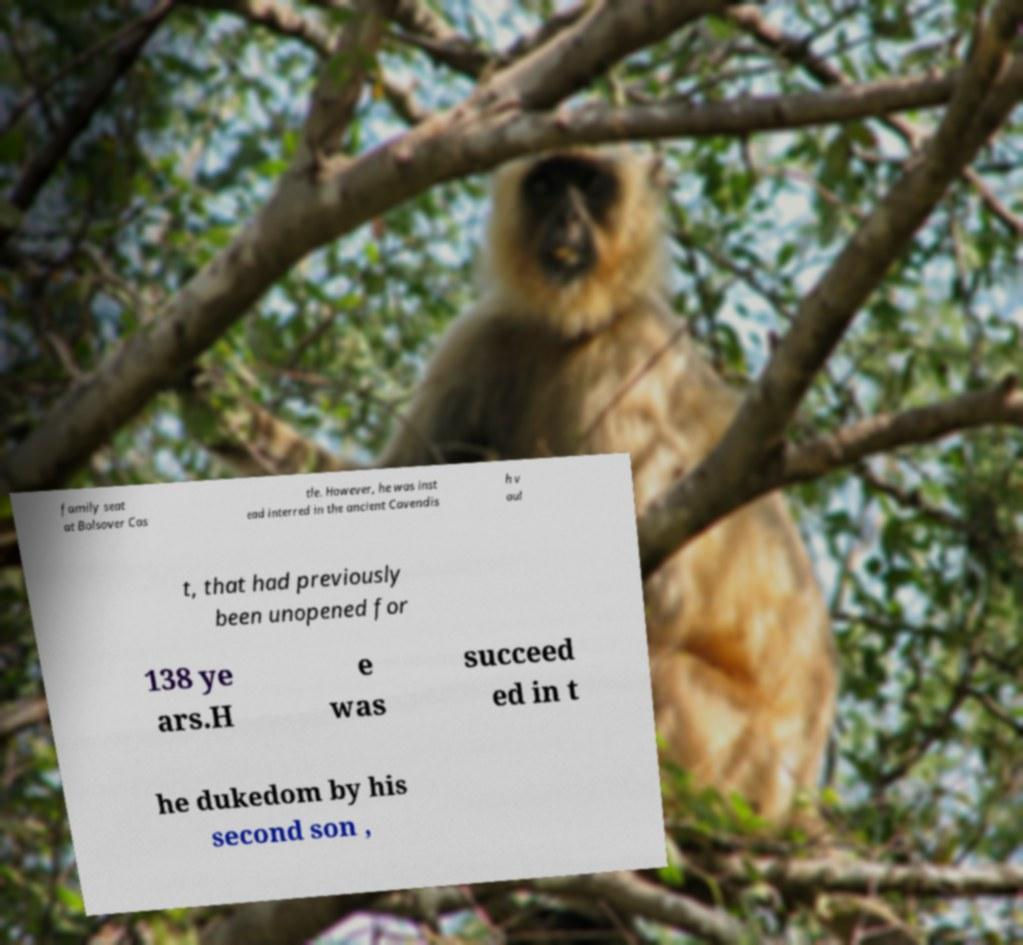There's text embedded in this image that I need extracted. Can you transcribe it verbatim? family seat at Bolsover Cas tle. However, he was inst ead interred in the ancient Cavendis h v aul t, that had previously been unopened for 138 ye ars.H e was succeed ed in t he dukedom by his second son , 